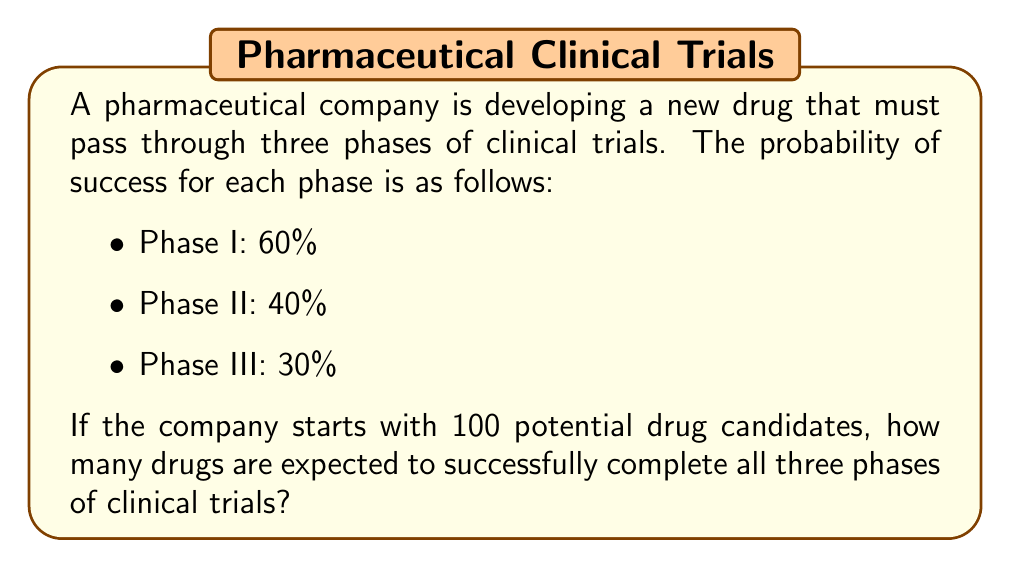Can you answer this question? To solve this problem, we'll use the multiplication principle of probability and the concept of expected value.

1) First, let's calculate the probability of a single drug passing all three phases:

   $P(\text{success}) = P(\text{Phase I}) \times P(\text{Phase II}) \times P(\text{Phase III})$
   $P(\text{success}) = 0.60 \times 0.40 \times 0.30 = 0.072$ or $7.2\%$

2) Now, we need to consider that we're starting with 100 drug candidates. The number of successful drugs is a binomial random variable $X \sim B(n,p)$ where:
   - $n = 100$ (number of trials)
   - $p = 0.072$ (probability of success for each trial)

3) The expected value of a binomial distribution is given by:

   $E(X) = n \times p$

4) Substituting our values:

   $E(X) = 100 \times 0.072 = 7.2$

Therefore, we expect 7.2 drugs to successfully complete all three phases of clinical trials.

5) Since we can't have a fractional number of drugs, we round to the nearest whole number: 7 drugs.
Answer: 7 drugs are expected to successfully complete all three phases of clinical trials. 